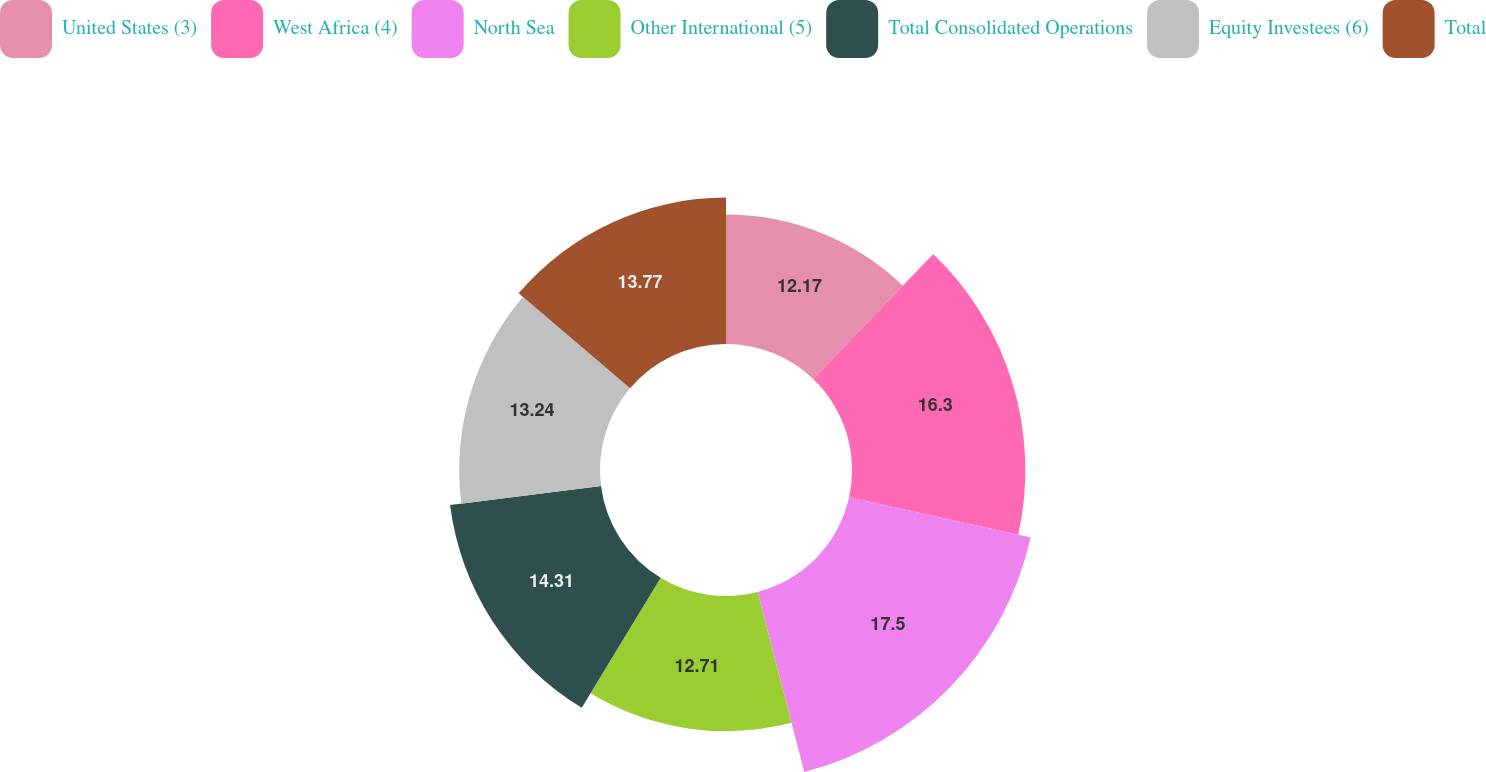<chart> <loc_0><loc_0><loc_500><loc_500><pie_chart><fcel>United States (3)<fcel>West Africa (4)<fcel>North Sea<fcel>Other International (5)<fcel>Total Consolidated Operations<fcel>Equity Investees (6)<fcel>Total<nl><fcel>12.17%<fcel>16.3%<fcel>17.49%<fcel>12.71%<fcel>14.31%<fcel>13.24%<fcel>13.77%<nl></chart> 